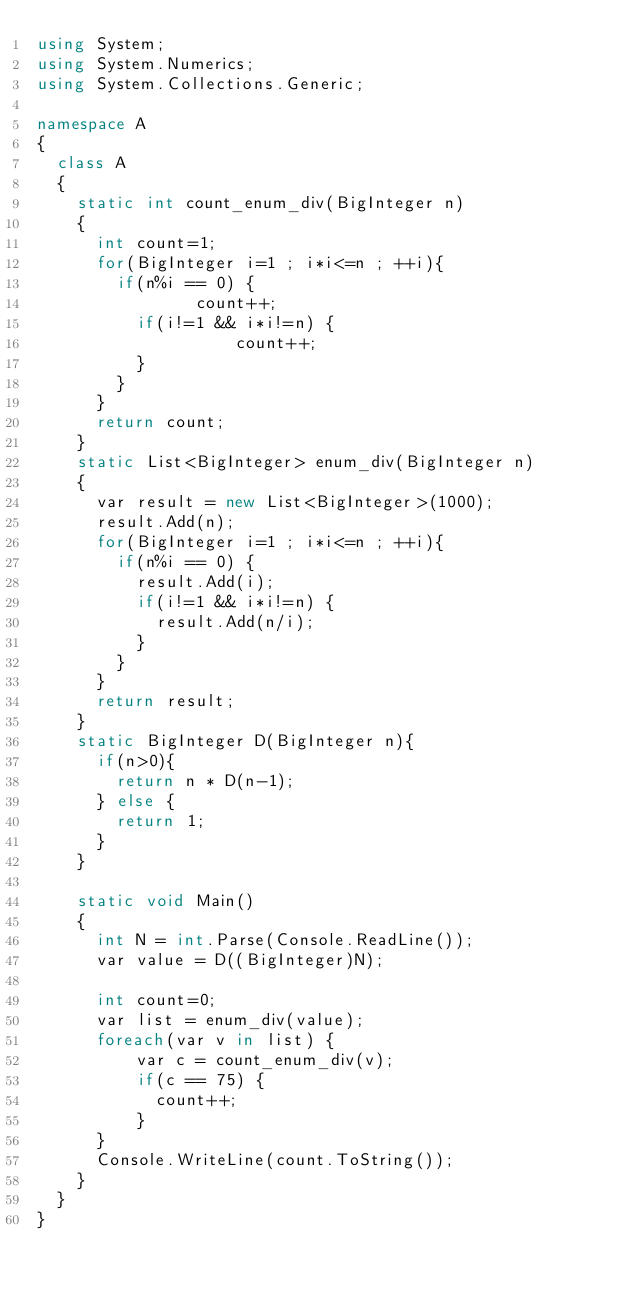<code> <loc_0><loc_0><loc_500><loc_500><_C#_>using System;
using System.Numerics;
using System.Collections.Generic;

namespace A
{
  class A 
  {
    static int count_enum_div(BigInteger n)
    {
    	int count=1;
    	for(BigInteger i=1 ; i*i<=n ; ++i){
    		if(n%i == 0) {
                count++;
    			if(i!=1 && i*i!=n) {
                    count++;
    			}
    		}
    	}
    	return count;
    }
    static List<BigInteger> enum_div(BigInteger n)
    {
      var result = new List<BigInteger>(1000);
      result.Add(n);
      for(BigInteger i=1 ; i*i<=n ; ++i){
        if(n%i == 0) {
          result.Add(i);
          if(i!=1 && i*i!=n) {
            result.Add(n/i);
          }
        }
      }
      return result;
    }
    static BigInteger D(BigInteger n){
      if(n>0){
        return n * D(n-1);
      } else {
        return 1;
      }
    }
    
    static void Main() 
    {
      int N = int.Parse(Console.ReadLine());
      var value = D((BigInteger)N);
      
      int count=0;
      var list = enum_div(value);
      foreach(var v in list) {
          var c = count_enum_div(v);
          if(c == 75) {
            count++;
          }
      }
      Console.WriteLine(count.ToString());
    }
  }
}</code> 